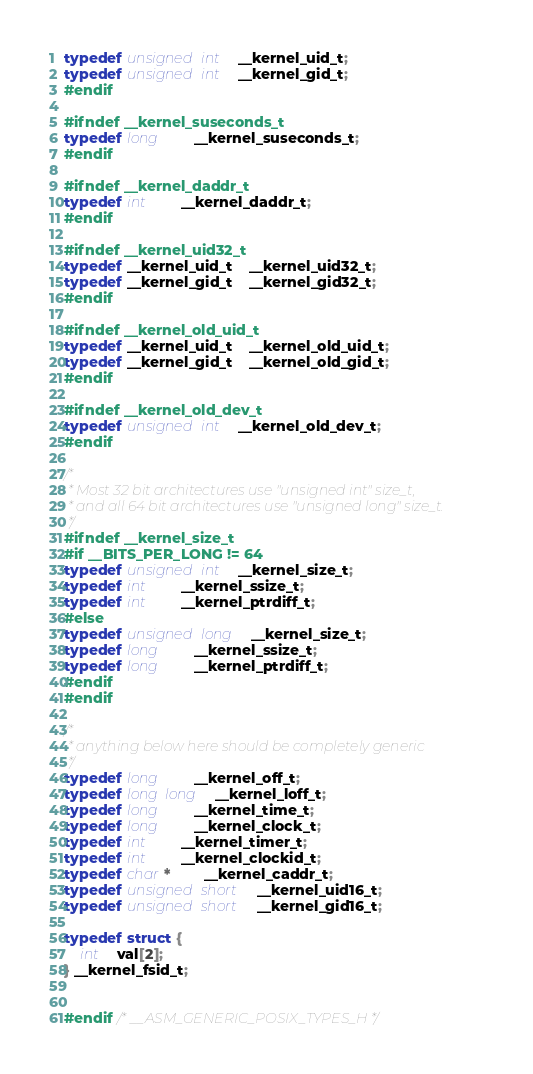<code> <loc_0><loc_0><loc_500><loc_500><_C_>typedef unsigned int	__kernel_uid_t;
typedef unsigned int	__kernel_gid_t;
#endif

#ifndef __kernel_suseconds_t
typedef long		__kernel_suseconds_t;
#endif

#ifndef __kernel_daddr_t
typedef int		__kernel_daddr_t;
#endif

#ifndef __kernel_uid32_t
typedef __kernel_uid_t	__kernel_uid32_t;
typedef __kernel_gid_t	__kernel_gid32_t;
#endif

#ifndef __kernel_old_uid_t
typedef __kernel_uid_t	__kernel_old_uid_t;
typedef __kernel_gid_t	__kernel_old_gid_t;
#endif

#ifndef __kernel_old_dev_t
typedef unsigned int	__kernel_old_dev_t;
#endif

/*
 * Most 32 bit architectures use "unsigned int" size_t,
 * and all 64 bit architectures use "unsigned long" size_t.
 */
#ifndef __kernel_size_t
#if __BITS_PER_LONG != 64
typedef unsigned int	__kernel_size_t;
typedef int		__kernel_ssize_t;
typedef int		__kernel_ptrdiff_t;
#else
typedef unsigned long	__kernel_size_t;
typedef long		__kernel_ssize_t;
typedef long		__kernel_ptrdiff_t;
#endif
#endif

/*
 * anything below here should be completely generic
 */
typedef long		__kernel_off_t;
typedef long long	__kernel_loff_t;
typedef long		__kernel_time_t;
typedef long		__kernel_clock_t;
typedef int		__kernel_timer_t;
typedef int		__kernel_clockid_t;
typedef char *		__kernel_caddr_t;
typedef unsigned short	__kernel_uid16_t;
typedef unsigned short	__kernel_gid16_t;

typedef struct {
	int	val[2];
} __kernel_fsid_t;


#endif /* __ASM_GENERIC_POSIX_TYPES_H */
</code> 